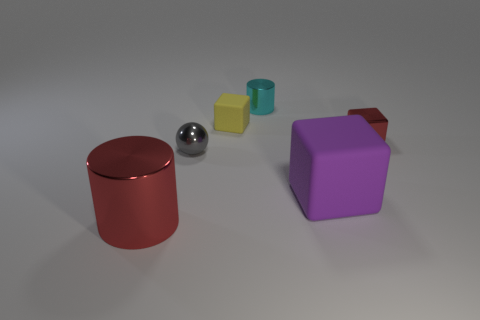Add 3 large objects. How many objects exist? 9 Subtract all balls. How many objects are left? 5 Add 6 large things. How many large things exist? 8 Subtract 0 blue spheres. How many objects are left? 6 Subtract all small cylinders. Subtract all gray metal spheres. How many objects are left? 4 Add 1 spheres. How many spheres are left? 2 